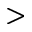<formula> <loc_0><loc_0><loc_500><loc_500>></formula> 